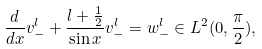Convert formula to latex. <formula><loc_0><loc_0><loc_500><loc_500>\frac { d } { d x } v ^ { l } _ { - } + \frac { l + \frac { 1 } { 2 } } { \sin x } v _ { - } ^ { l } = w _ { - } ^ { l } \in L ^ { 2 } ( 0 , \frac { \pi } { 2 } ) ,</formula> 